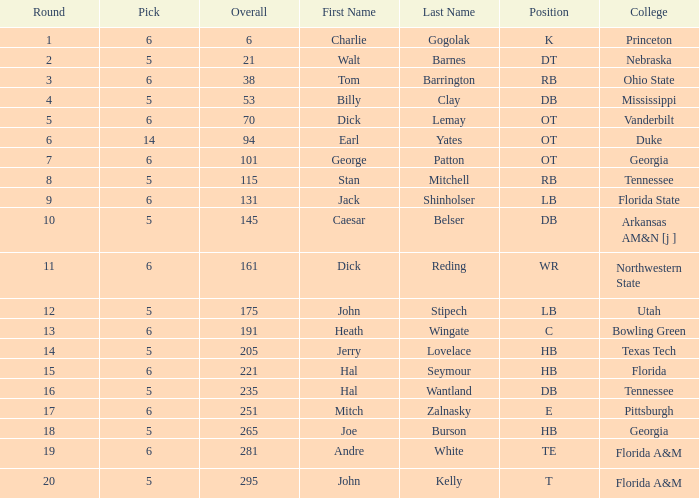What is Name, when Overall is less than 175, and when College is "Georgia"? George Patton. 